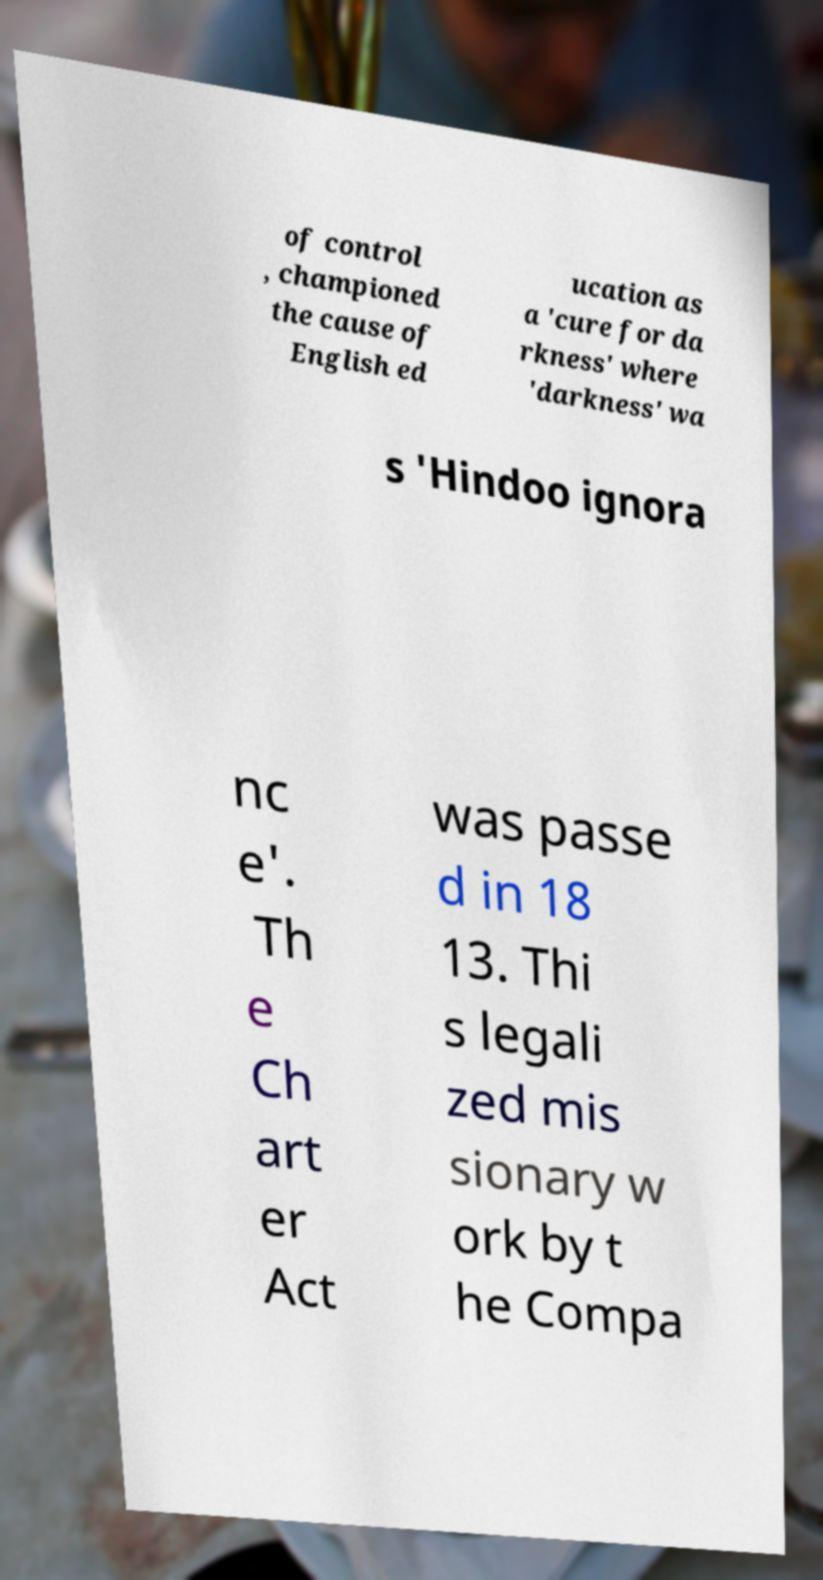Can you accurately transcribe the text from the provided image for me? of control , championed the cause of English ed ucation as a 'cure for da rkness' where 'darkness' wa s 'Hindoo ignora nc e'. Th e Ch art er Act was passe d in 18 13. Thi s legali zed mis sionary w ork by t he Compa 